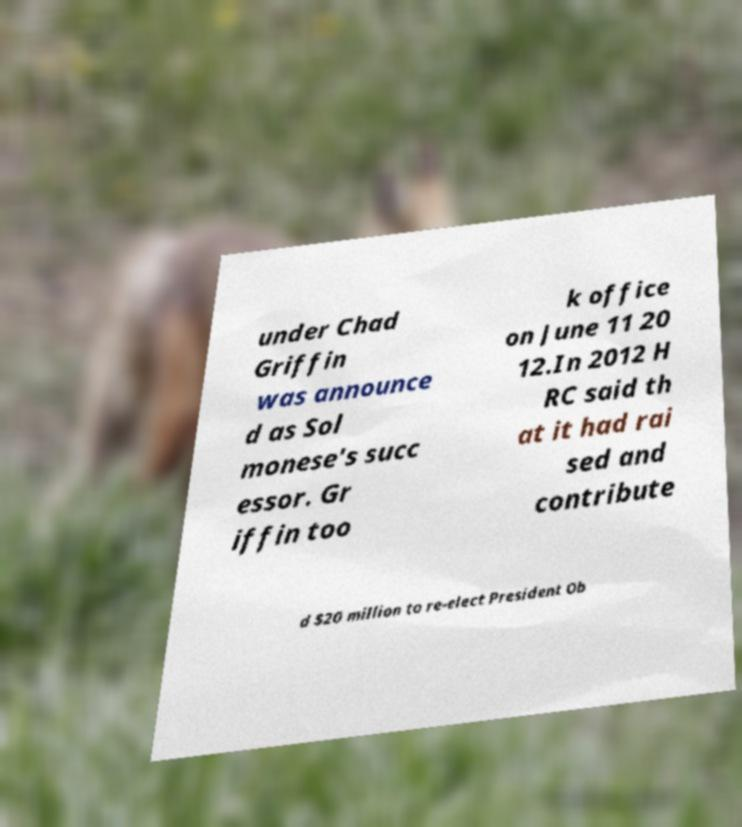Could you assist in decoding the text presented in this image and type it out clearly? under Chad Griffin was announce d as Sol monese's succ essor. Gr iffin too k office on June 11 20 12.In 2012 H RC said th at it had rai sed and contribute d $20 million to re-elect President Ob 